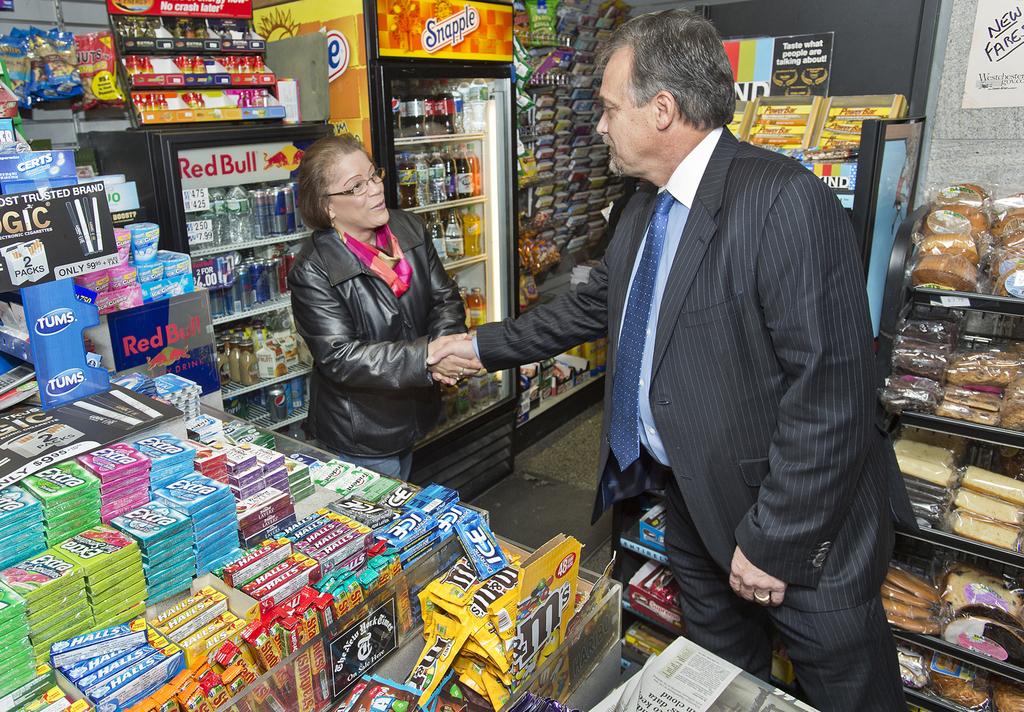What snack is in a yellow back front and center?
Offer a terse response. M&ms. What brand of gum is on the left in boxes stacked high?
Keep it short and to the point. Extra. 